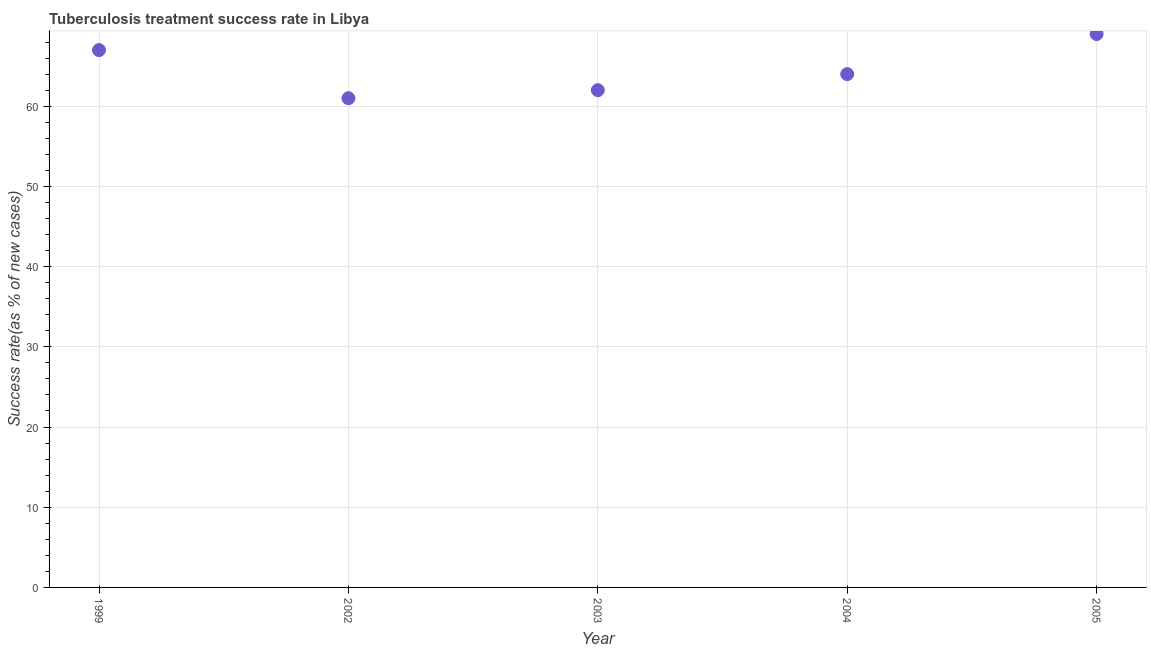What is the tuberculosis treatment success rate in 1999?
Make the answer very short. 67. Across all years, what is the maximum tuberculosis treatment success rate?
Offer a terse response. 69. Across all years, what is the minimum tuberculosis treatment success rate?
Give a very brief answer. 61. In which year was the tuberculosis treatment success rate maximum?
Ensure brevity in your answer.  2005. What is the sum of the tuberculosis treatment success rate?
Your response must be concise. 323. What is the difference between the tuberculosis treatment success rate in 2003 and 2005?
Your answer should be compact. -7. What is the average tuberculosis treatment success rate per year?
Make the answer very short. 64.6. In how many years, is the tuberculosis treatment success rate greater than 12 %?
Your answer should be very brief. 5. Do a majority of the years between 2005 and 2002 (inclusive) have tuberculosis treatment success rate greater than 40 %?
Keep it short and to the point. Yes. What is the ratio of the tuberculosis treatment success rate in 2002 to that in 2005?
Make the answer very short. 0.88. Is the difference between the tuberculosis treatment success rate in 2003 and 2005 greater than the difference between any two years?
Your answer should be very brief. No. What is the difference between the highest and the second highest tuberculosis treatment success rate?
Provide a short and direct response. 2. What is the difference between the highest and the lowest tuberculosis treatment success rate?
Your response must be concise. 8. In how many years, is the tuberculosis treatment success rate greater than the average tuberculosis treatment success rate taken over all years?
Give a very brief answer. 2. Does the tuberculosis treatment success rate monotonically increase over the years?
Provide a succinct answer. No. How many years are there in the graph?
Your response must be concise. 5. Does the graph contain any zero values?
Give a very brief answer. No. Does the graph contain grids?
Provide a succinct answer. Yes. What is the title of the graph?
Provide a succinct answer. Tuberculosis treatment success rate in Libya. What is the label or title of the X-axis?
Keep it short and to the point. Year. What is the label or title of the Y-axis?
Keep it short and to the point. Success rate(as % of new cases). What is the difference between the Success rate(as % of new cases) in 1999 and 2002?
Provide a succinct answer. 6. What is the difference between the Success rate(as % of new cases) in 1999 and 2003?
Your answer should be compact. 5. What is the difference between the Success rate(as % of new cases) in 1999 and 2004?
Give a very brief answer. 3. What is the difference between the Success rate(as % of new cases) in 2002 and 2004?
Give a very brief answer. -3. What is the ratio of the Success rate(as % of new cases) in 1999 to that in 2002?
Your response must be concise. 1.1. What is the ratio of the Success rate(as % of new cases) in 1999 to that in 2003?
Your answer should be very brief. 1.08. What is the ratio of the Success rate(as % of new cases) in 1999 to that in 2004?
Offer a very short reply. 1.05. What is the ratio of the Success rate(as % of new cases) in 2002 to that in 2003?
Offer a terse response. 0.98. What is the ratio of the Success rate(as % of new cases) in 2002 to that in 2004?
Your answer should be very brief. 0.95. What is the ratio of the Success rate(as % of new cases) in 2002 to that in 2005?
Provide a short and direct response. 0.88. What is the ratio of the Success rate(as % of new cases) in 2003 to that in 2005?
Offer a terse response. 0.9. What is the ratio of the Success rate(as % of new cases) in 2004 to that in 2005?
Offer a very short reply. 0.93. 